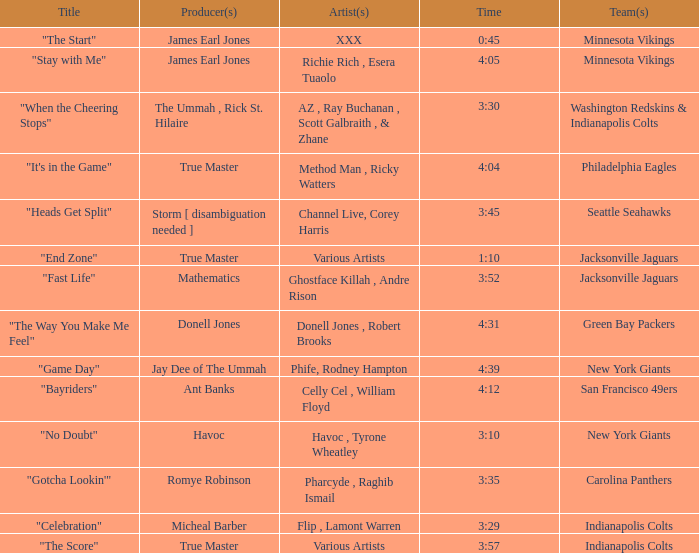Who produced "Fast Life"? Mathematics. 